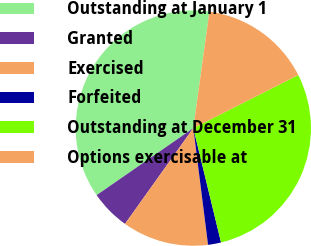Convert chart. <chart><loc_0><loc_0><loc_500><loc_500><pie_chart><fcel>Outstanding at January 1<fcel>Granted<fcel>Exercised<fcel>Forfeited<fcel>Outstanding at December 31<fcel>Options exercisable at<nl><fcel>36.83%<fcel>5.49%<fcel>11.86%<fcel>1.79%<fcel>28.67%<fcel>15.36%<nl></chart> 